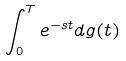<formula> <loc_0><loc_0><loc_500><loc_500>\int _ { 0 } ^ { T } e ^ { - s t } d g ( t )</formula> 